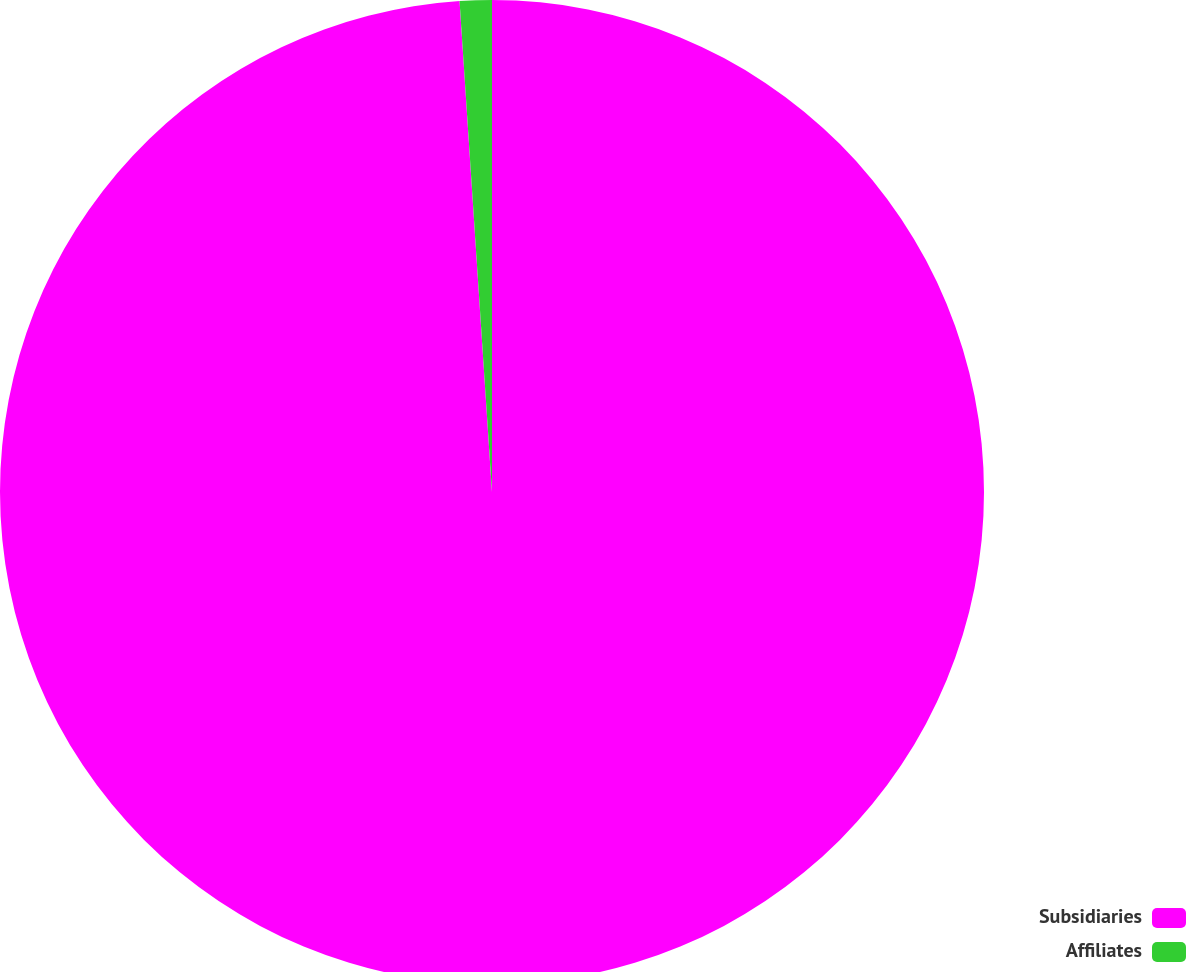Convert chart. <chart><loc_0><loc_0><loc_500><loc_500><pie_chart><fcel>Subsidiaries<fcel>Affiliates<nl><fcel>98.95%<fcel>1.05%<nl></chart> 